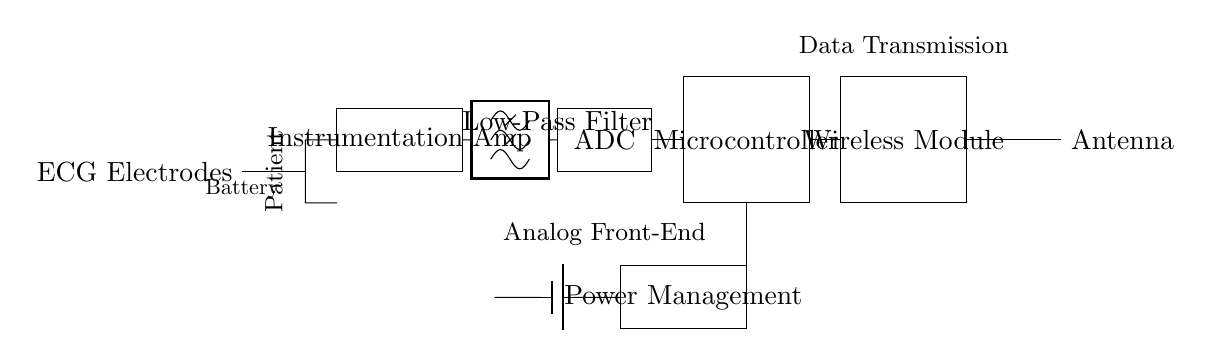What type of amplifier is shown in the circuit? The circuit diagram includes an instrumentation amplifier, specifically designed to amplify small differential signals from the electrodes.
Answer: Instrumentation amplifier What is the purpose of the low-pass filter in this circuit? The low-pass filter is used to remove high-frequency noise from the ECG signal, ensuring that only the desired low-frequency information is passed through for further processing.
Answer: Noise reduction How many main sections are identified in the data transmission part of the circuit? The data transmission part consists of three main sections: the microcontroller, the wireless module, and the antenna, all working together to transmit processed data wirelessly.
Answer: Three Which component is responsible for converting analog signals to digital? The analog-to-digital converter (ADC) is responsible for converting the analog ECG signal from the instrumentation amplifier into a digital signal for processing by the microcontroller.
Answer: ADC What role does the battery play in this circuit? The battery provides the necessary power supply to all components in the circuit, ensuring that the entire system operates smoothly without an external power source.
Answer: Power supply What type of power management system is included in the circuit? The power management system regulates and distributes battery power to various components in the circuit, ensuring efficient operation and preventing damage due to over-voltage or under-voltage conditions.
Answer: Power management How is the ECG data transmitted from the device? The ECG data is transmitted wirelessly via the wireless module and antenna, which send the data to a receiver for monitoring and analysis.
Answer: Wireless transmission 